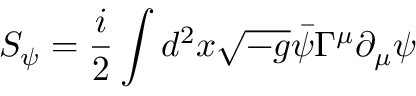<formula> <loc_0><loc_0><loc_500><loc_500>S _ { \psi } = \frac { i } { 2 } \int d ^ { 2 } x \sqrt { - g } \bar { \psi } \Gamma ^ { \mu } \partial _ { \mu } \psi</formula> 